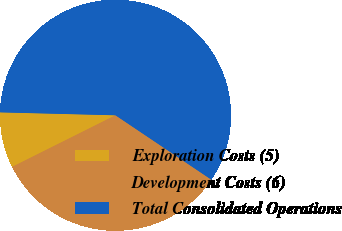Convert chart. <chart><loc_0><loc_0><loc_500><loc_500><pie_chart><fcel>Exploration Costs (5)<fcel>Development Costs (6)<fcel>Total Consolidated Operations<nl><fcel>7.78%<fcel>33.21%<fcel>59.01%<nl></chart> 